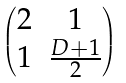Convert formula to latex. <formula><loc_0><loc_0><loc_500><loc_500>\begin{pmatrix} 2 & 1 \\ 1 & \frac { D + 1 } 2 \end{pmatrix}</formula> 